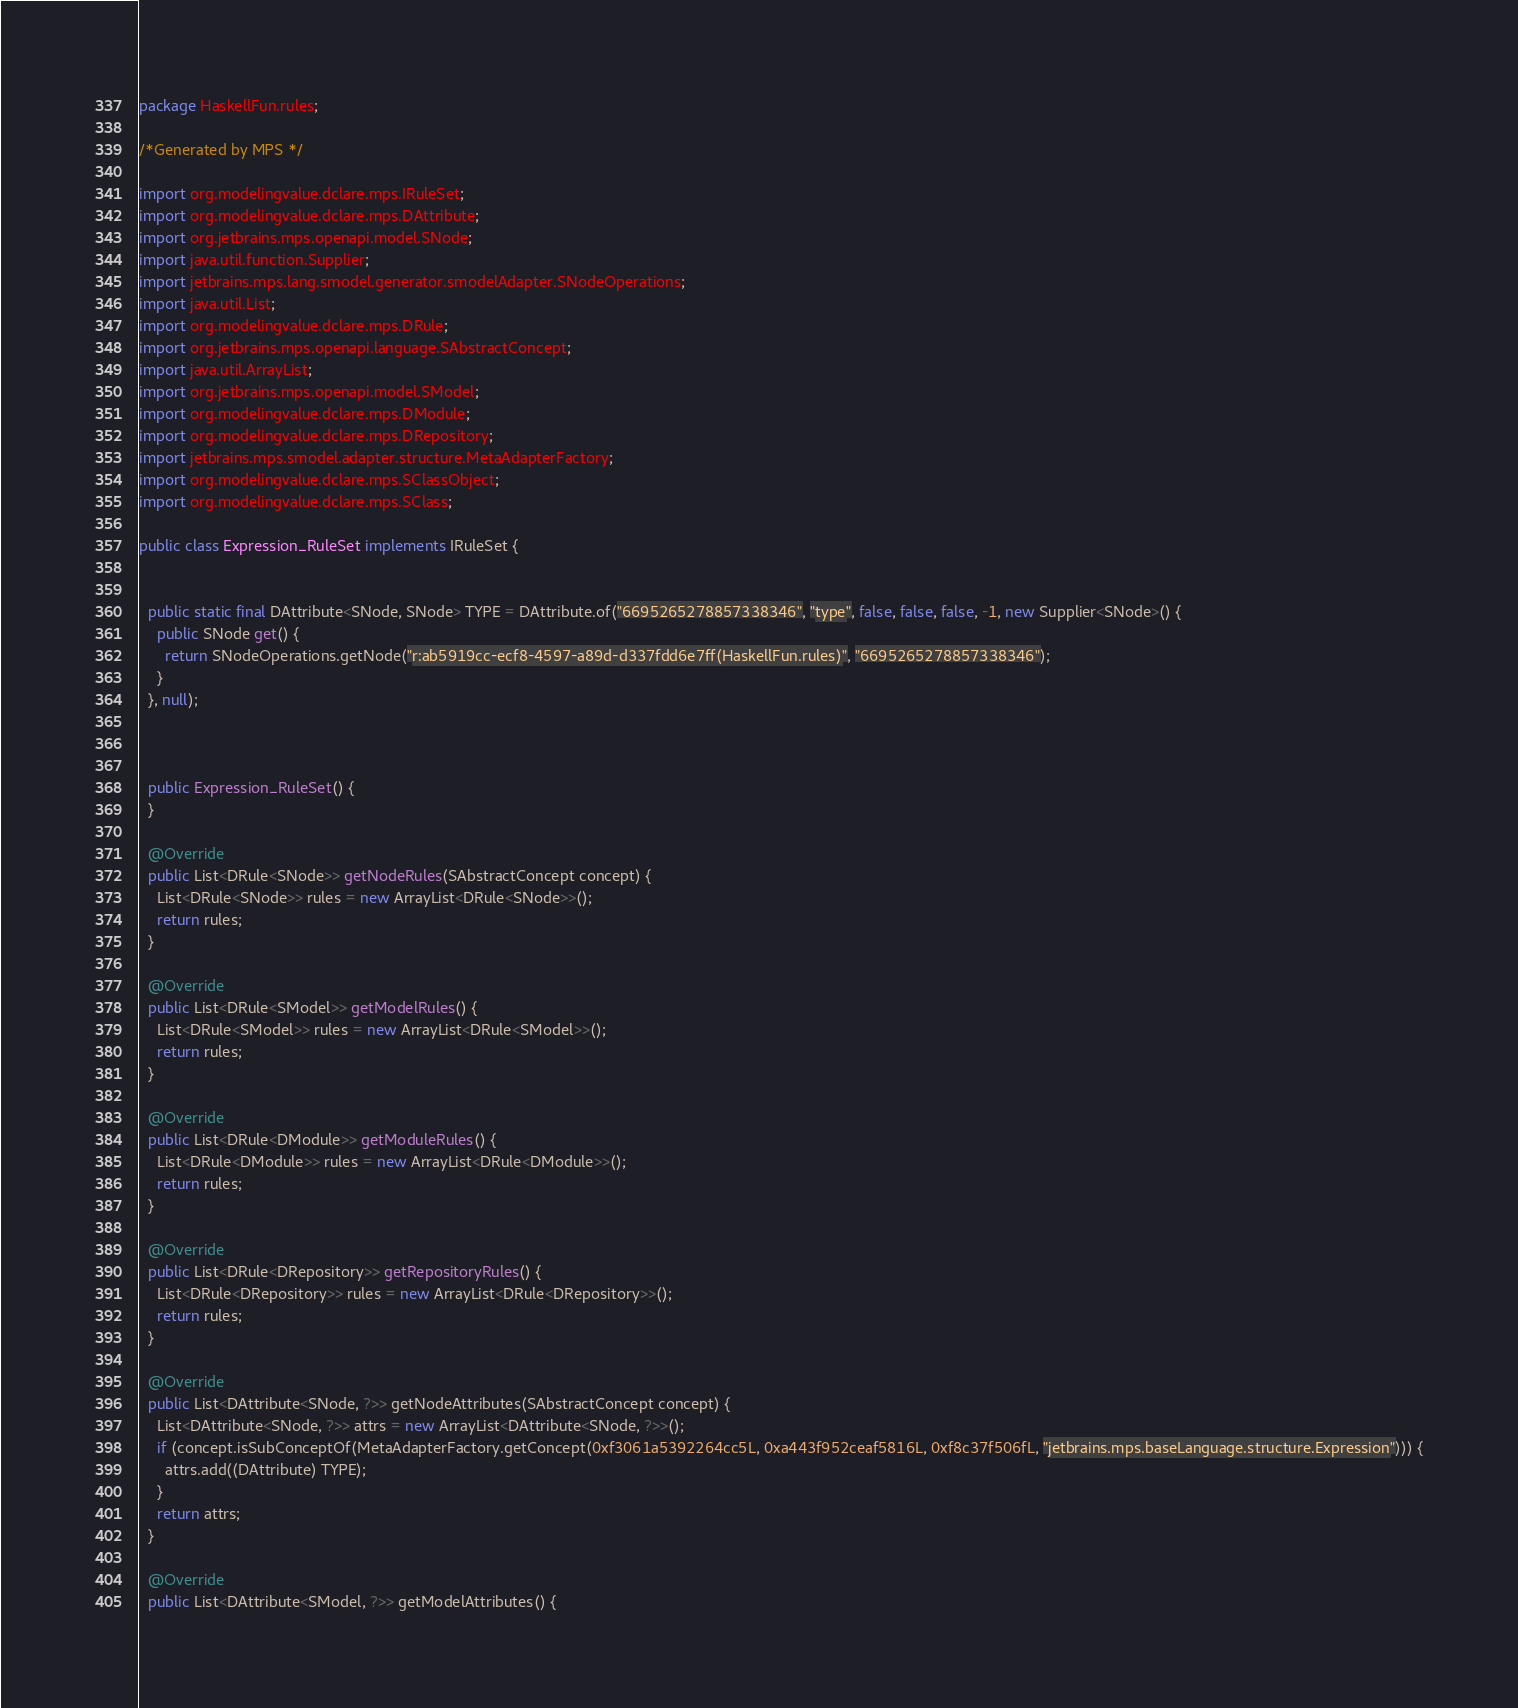<code> <loc_0><loc_0><loc_500><loc_500><_Java_>package HaskellFun.rules;

/*Generated by MPS */

import org.modelingvalue.dclare.mps.IRuleSet;
import org.modelingvalue.dclare.mps.DAttribute;
import org.jetbrains.mps.openapi.model.SNode;
import java.util.function.Supplier;
import jetbrains.mps.lang.smodel.generator.smodelAdapter.SNodeOperations;
import java.util.List;
import org.modelingvalue.dclare.mps.DRule;
import org.jetbrains.mps.openapi.language.SAbstractConcept;
import java.util.ArrayList;
import org.jetbrains.mps.openapi.model.SModel;
import org.modelingvalue.dclare.mps.DModule;
import org.modelingvalue.dclare.mps.DRepository;
import jetbrains.mps.smodel.adapter.structure.MetaAdapterFactory;
import org.modelingvalue.dclare.mps.SClassObject;
import org.modelingvalue.dclare.mps.SClass;

public class Expression_RuleSet implements IRuleSet {


  public static final DAttribute<SNode, SNode> TYPE = DAttribute.of("6695265278857338346", "type", false, false, false, -1, new Supplier<SNode>() {
    public SNode get() {
      return SNodeOperations.getNode("r:ab5919cc-ecf8-4597-a89d-d337fdd6e7ff(HaskellFun.rules)", "6695265278857338346");
    }
  }, null);



  public Expression_RuleSet() {
  }

  @Override
  public List<DRule<SNode>> getNodeRules(SAbstractConcept concept) {
    List<DRule<SNode>> rules = new ArrayList<DRule<SNode>>();
    return rules;
  }

  @Override
  public List<DRule<SModel>> getModelRules() {
    List<DRule<SModel>> rules = new ArrayList<DRule<SModel>>();
    return rules;
  }

  @Override
  public List<DRule<DModule>> getModuleRules() {
    List<DRule<DModule>> rules = new ArrayList<DRule<DModule>>();
    return rules;
  }

  @Override
  public List<DRule<DRepository>> getRepositoryRules() {
    List<DRule<DRepository>> rules = new ArrayList<DRule<DRepository>>();
    return rules;
  }

  @Override
  public List<DAttribute<SNode, ?>> getNodeAttributes(SAbstractConcept concept) {
    List<DAttribute<SNode, ?>> attrs = new ArrayList<DAttribute<SNode, ?>>();
    if (concept.isSubConceptOf(MetaAdapterFactory.getConcept(0xf3061a5392264cc5L, 0xa443f952ceaf5816L, 0xf8c37f506fL, "jetbrains.mps.baseLanguage.structure.Expression"))) {
      attrs.add((DAttribute) TYPE);
    }
    return attrs;
  }

  @Override
  public List<DAttribute<SModel, ?>> getModelAttributes() {</code> 